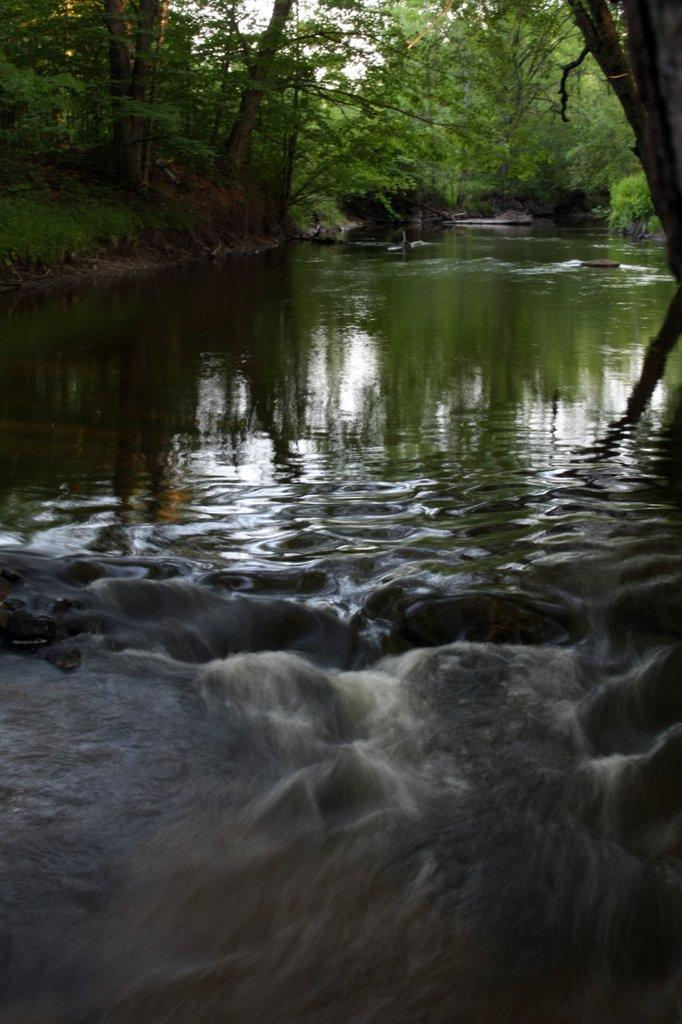What is the primary element visible in the image? There is water in the image. What type of vegetation can be seen in the image? Trees are present at the back of the image. What type of voice can be heard coming from the trees in the image? There is no voice present in the image, as it is a still image and does not contain any sounds. 